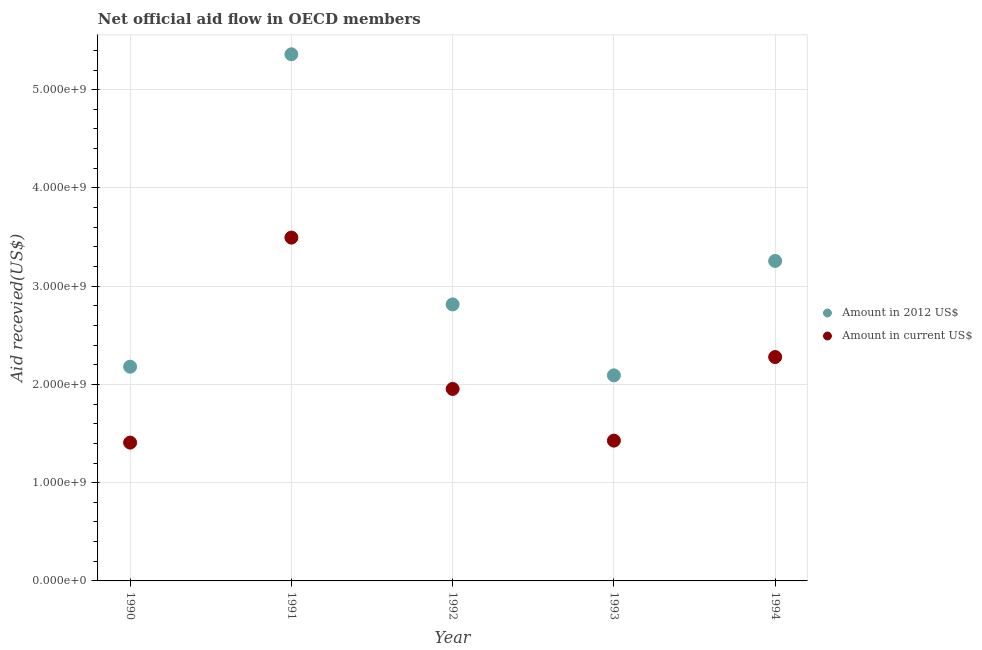What is the amount of aid received(expressed in us$) in 1993?
Your response must be concise. 1.43e+09. Across all years, what is the maximum amount of aid received(expressed in 2012 us$)?
Keep it short and to the point. 5.36e+09. Across all years, what is the minimum amount of aid received(expressed in us$)?
Offer a terse response. 1.41e+09. In which year was the amount of aid received(expressed in us$) maximum?
Provide a short and direct response. 1991. What is the total amount of aid received(expressed in 2012 us$) in the graph?
Your answer should be compact. 1.57e+1. What is the difference between the amount of aid received(expressed in 2012 us$) in 1990 and that in 1993?
Provide a short and direct response. 8.80e+07. What is the difference between the amount of aid received(expressed in 2012 us$) in 1990 and the amount of aid received(expressed in us$) in 1991?
Offer a terse response. -1.31e+09. What is the average amount of aid received(expressed in 2012 us$) per year?
Offer a terse response. 3.14e+09. In the year 1990, what is the difference between the amount of aid received(expressed in 2012 us$) and amount of aid received(expressed in us$)?
Give a very brief answer. 7.73e+08. In how many years, is the amount of aid received(expressed in 2012 us$) greater than 4200000000 US$?
Your answer should be very brief. 1. What is the ratio of the amount of aid received(expressed in us$) in 1991 to that in 1992?
Make the answer very short. 1.79. Is the amount of aid received(expressed in us$) in 1990 less than that in 1994?
Give a very brief answer. Yes. Is the difference between the amount of aid received(expressed in 2012 us$) in 1993 and 1994 greater than the difference between the amount of aid received(expressed in us$) in 1993 and 1994?
Your answer should be compact. No. What is the difference between the highest and the second highest amount of aid received(expressed in us$)?
Your answer should be very brief. 1.22e+09. What is the difference between the highest and the lowest amount of aid received(expressed in 2012 us$)?
Your answer should be compact. 3.27e+09. In how many years, is the amount of aid received(expressed in us$) greater than the average amount of aid received(expressed in us$) taken over all years?
Your response must be concise. 2. Is the sum of the amount of aid received(expressed in 2012 us$) in 1991 and 1992 greater than the maximum amount of aid received(expressed in us$) across all years?
Ensure brevity in your answer.  Yes. Is the amount of aid received(expressed in us$) strictly less than the amount of aid received(expressed in 2012 us$) over the years?
Ensure brevity in your answer.  Yes. What is the difference between two consecutive major ticks on the Y-axis?
Provide a short and direct response. 1.00e+09. Are the values on the major ticks of Y-axis written in scientific E-notation?
Provide a short and direct response. Yes. Does the graph contain grids?
Offer a very short reply. Yes. How are the legend labels stacked?
Make the answer very short. Vertical. What is the title of the graph?
Ensure brevity in your answer.  Net official aid flow in OECD members. What is the label or title of the X-axis?
Your answer should be very brief. Year. What is the label or title of the Y-axis?
Provide a short and direct response. Aid recevied(US$). What is the Aid recevied(US$) in Amount in 2012 US$ in 1990?
Your answer should be compact. 2.18e+09. What is the Aid recevied(US$) in Amount in current US$ in 1990?
Give a very brief answer. 1.41e+09. What is the Aid recevied(US$) of Amount in 2012 US$ in 1991?
Your answer should be very brief. 5.36e+09. What is the Aid recevied(US$) of Amount in current US$ in 1991?
Your answer should be compact. 3.49e+09. What is the Aid recevied(US$) in Amount in 2012 US$ in 1992?
Your response must be concise. 2.81e+09. What is the Aid recevied(US$) in Amount in current US$ in 1992?
Your answer should be compact. 1.95e+09. What is the Aid recevied(US$) of Amount in 2012 US$ in 1993?
Your answer should be very brief. 2.09e+09. What is the Aid recevied(US$) in Amount in current US$ in 1993?
Your response must be concise. 1.43e+09. What is the Aid recevied(US$) in Amount in 2012 US$ in 1994?
Your response must be concise. 3.26e+09. What is the Aid recevied(US$) of Amount in current US$ in 1994?
Keep it short and to the point. 2.28e+09. Across all years, what is the maximum Aid recevied(US$) of Amount in 2012 US$?
Make the answer very short. 5.36e+09. Across all years, what is the maximum Aid recevied(US$) of Amount in current US$?
Give a very brief answer. 3.49e+09. Across all years, what is the minimum Aid recevied(US$) of Amount in 2012 US$?
Offer a terse response. 2.09e+09. Across all years, what is the minimum Aid recevied(US$) of Amount in current US$?
Your answer should be compact. 1.41e+09. What is the total Aid recevied(US$) in Amount in 2012 US$ in the graph?
Ensure brevity in your answer.  1.57e+1. What is the total Aid recevied(US$) in Amount in current US$ in the graph?
Give a very brief answer. 1.06e+1. What is the difference between the Aid recevied(US$) in Amount in 2012 US$ in 1990 and that in 1991?
Ensure brevity in your answer.  -3.18e+09. What is the difference between the Aid recevied(US$) in Amount in current US$ in 1990 and that in 1991?
Make the answer very short. -2.09e+09. What is the difference between the Aid recevied(US$) in Amount in 2012 US$ in 1990 and that in 1992?
Offer a very short reply. -6.34e+08. What is the difference between the Aid recevied(US$) of Amount in current US$ in 1990 and that in 1992?
Provide a succinct answer. -5.46e+08. What is the difference between the Aid recevied(US$) of Amount in 2012 US$ in 1990 and that in 1993?
Your answer should be very brief. 8.80e+07. What is the difference between the Aid recevied(US$) of Amount in current US$ in 1990 and that in 1993?
Provide a succinct answer. -2.01e+07. What is the difference between the Aid recevied(US$) of Amount in 2012 US$ in 1990 and that in 1994?
Provide a short and direct response. -1.08e+09. What is the difference between the Aid recevied(US$) in Amount in current US$ in 1990 and that in 1994?
Provide a succinct answer. -8.71e+08. What is the difference between the Aid recevied(US$) of Amount in 2012 US$ in 1991 and that in 1992?
Provide a short and direct response. 2.55e+09. What is the difference between the Aid recevied(US$) of Amount in current US$ in 1991 and that in 1992?
Make the answer very short. 1.54e+09. What is the difference between the Aid recevied(US$) in Amount in 2012 US$ in 1991 and that in 1993?
Offer a very short reply. 3.27e+09. What is the difference between the Aid recevied(US$) of Amount in current US$ in 1991 and that in 1993?
Your answer should be very brief. 2.07e+09. What is the difference between the Aid recevied(US$) of Amount in 2012 US$ in 1991 and that in 1994?
Offer a terse response. 2.10e+09. What is the difference between the Aid recevied(US$) of Amount in current US$ in 1991 and that in 1994?
Your answer should be compact. 1.22e+09. What is the difference between the Aid recevied(US$) in Amount in 2012 US$ in 1992 and that in 1993?
Keep it short and to the point. 7.22e+08. What is the difference between the Aid recevied(US$) of Amount in current US$ in 1992 and that in 1993?
Give a very brief answer. 5.26e+08. What is the difference between the Aid recevied(US$) in Amount in 2012 US$ in 1992 and that in 1994?
Offer a very short reply. -4.43e+08. What is the difference between the Aid recevied(US$) of Amount in current US$ in 1992 and that in 1994?
Provide a short and direct response. -3.25e+08. What is the difference between the Aid recevied(US$) of Amount in 2012 US$ in 1993 and that in 1994?
Offer a terse response. -1.16e+09. What is the difference between the Aid recevied(US$) of Amount in current US$ in 1993 and that in 1994?
Make the answer very short. -8.51e+08. What is the difference between the Aid recevied(US$) of Amount in 2012 US$ in 1990 and the Aid recevied(US$) of Amount in current US$ in 1991?
Your answer should be very brief. -1.31e+09. What is the difference between the Aid recevied(US$) in Amount in 2012 US$ in 1990 and the Aid recevied(US$) in Amount in current US$ in 1992?
Keep it short and to the point. 2.26e+08. What is the difference between the Aid recevied(US$) of Amount in 2012 US$ in 1990 and the Aid recevied(US$) of Amount in current US$ in 1993?
Your response must be concise. 7.53e+08. What is the difference between the Aid recevied(US$) in Amount in 2012 US$ in 1990 and the Aid recevied(US$) in Amount in current US$ in 1994?
Make the answer very short. -9.86e+07. What is the difference between the Aid recevied(US$) in Amount in 2012 US$ in 1991 and the Aid recevied(US$) in Amount in current US$ in 1992?
Your answer should be compact. 3.41e+09. What is the difference between the Aid recevied(US$) in Amount in 2012 US$ in 1991 and the Aid recevied(US$) in Amount in current US$ in 1993?
Make the answer very short. 3.93e+09. What is the difference between the Aid recevied(US$) of Amount in 2012 US$ in 1991 and the Aid recevied(US$) of Amount in current US$ in 1994?
Your response must be concise. 3.08e+09. What is the difference between the Aid recevied(US$) of Amount in 2012 US$ in 1992 and the Aid recevied(US$) of Amount in current US$ in 1993?
Offer a terse response. 1.39e+09. What is the difference between the Aid recevied(US$) in Amount in 2012 US$ in 1992 and the Aid recevied(US$) in Amount in current US$ in 1994?
Your response must be concise. 5.35e+08. What is the difference between the Aid recevied(US$) of Amount in 2012 US$ in 1993 and the Aid recevied(US$) of Amount in current US$ in 1994?
Offer a terse response. -1.87e+08. What is the average Aid recevied(US$) in Amount in 2012 US$ per year?
Your answer should be very brief. 3.14e+09. What is the average Aid recevied(US$) of Amount in current US$ per year?
Your answer should be very brief. 2.11e+09. In the year 1990, what is the difference between the Aid recevied(US$) in Amount in 2012 US$ and Aid recevied(US$) in Amount in current US$?
Offer a very short reply. 7.73e+08. In the year 1991, what is the difference between the Aid recevied(US$) of Amount in 2012 US$ and Aid recevied(US$) of Amount in current US$?
Make the answer very short. 1.87e+09. In the year 1992, what is the difference between the Aid recevied(US$) in Amount in 2012 US$ and Aid recevied(US$) in Amount in current US$?
Ensure brevity in your answer.  8.60e+08. In the year 1993, what is the difference between the Aid recevied(US$) of Amount in 2012 US$ and Aid recevied(US$) of Amount in current US$?
Give a very brief answer. 6.65e+08. In the year 1994, what is the difference between the Aid recevied(US$) in Amount in 2012 US$ and Aid recevied(US$) in Amount in current US$?
Give a very brief answer. 9.78e+08. What is the ratio of the Aid recevied(US$) in Amount in 2012 US$ in 1990 to that in 1991?
Give a very brief answer. 0.41. What is the ratio of the Aid recevied(US$) in Amount in current US$ in 1990 to that in 1991?
Your answer should be compact. 0.4. What is the ratio of the Aid recevied(US$) in Amount in 2012 US$ in 1990 to that in 1992?
Your answer should be compact. 0.77. What is the ratio of the Aid recevied(US$) in Amount in current US$ in 1990 to that in 1992?
Provide a succinct answer. 0.72. What is the ratio of the Aid recevied(US$) in Amount in 2012 US$ in 1990 to that in 1993?
Ensure brevity in your answer.  1.04. What is the ratio of the Aid recevied(US$) of Amount in current US$ in 1990 to that in 1993?
Keep it short and to the point. 0.99. What is the ratio of the Aid recevied(US$) of Amount in 2012 US$ in 1990 to that in 1994?
Provide a short and direct response. 0.67. What is the ratio of the Aid recevied(US$) in Amount in current US$ in 1990 to that in 1994?
Make the answer very short. 0.62. What is the ratio of the Aid recevied(US$) in Amount in 2012 US$ in 1991 to that in 1992?
Give a very brief answer. 1.9. What is the ratio of the Aid recevied(US$) in Amount in current US$ in 1991 to that in 1992?
Make the answer very short. 1.79. What is the ratio of the Aid recevied(US$) in Amount in 2012 US$ in 1991 to that in 1993?
Provide a succinct answer. 2.56. What is the ratio of the Aid recevied(US$) in Amount in current US$ in 1991 to that in 1993?
Make the answer very short. 2.45. What is the ratio of the Aid recevied(US$) of Amount in 2012 US$ in 1991 to that in 1994?
Offer a very short reply. 1.65. What is the ratio of the Aid recevied(US$) in Amount in current US$ in 1991 to that in 1994?
Ensure brevity in your answer.  1.53. What is the ratio of the Aid recevied(US$) of Amount in 2012 US$ in 1992 to that in 1993?
Make the answer very short. 1.34. What is the ratio of the Aid recevied(US$) in Amount in current US$ in 1992 to that in 1993?
Offer a terse response. 1.37. What is the ratio of the Aid recevied(US$) in Amount in 2012 US$ in 1992 to that in 1994?
Offer a terse response. 0.86. What is the ratio of the Aid recevied(US$) in Amount in current US$ in 1992 to that in 1994?
Provide a succinct answer. 0.86. What is the ratio of the Aid recevied(US$) in Amount in 2012 US$ in 1993 to that in 1994?
Provide a short and direct response. 0.64. What is the ratio of the Aid recevied(US$) of Amount in current US$ in 1993 to that in 1994?
Your response must be concise. 0.63. What is the difference between the highest and the second highest Aid recevied(US$) in Amount in 2012 US$?
Your answer should be very brief. 2.10e+09. What is the difference between the highest and the second highest Aid recevied(US$) of Amount in current US$?
Offer a very short reply. 1.22e+09. What is the difference between the highest and the lowest Aid recevied(US$) of Amount in 2012 US$?
Your answer should be very brief. 3.27e+09. What is the difference between the highest and the lowest Aid recevied(US$) of Amount in current US$?
Provide a short and direct response. 2.09e+09. 